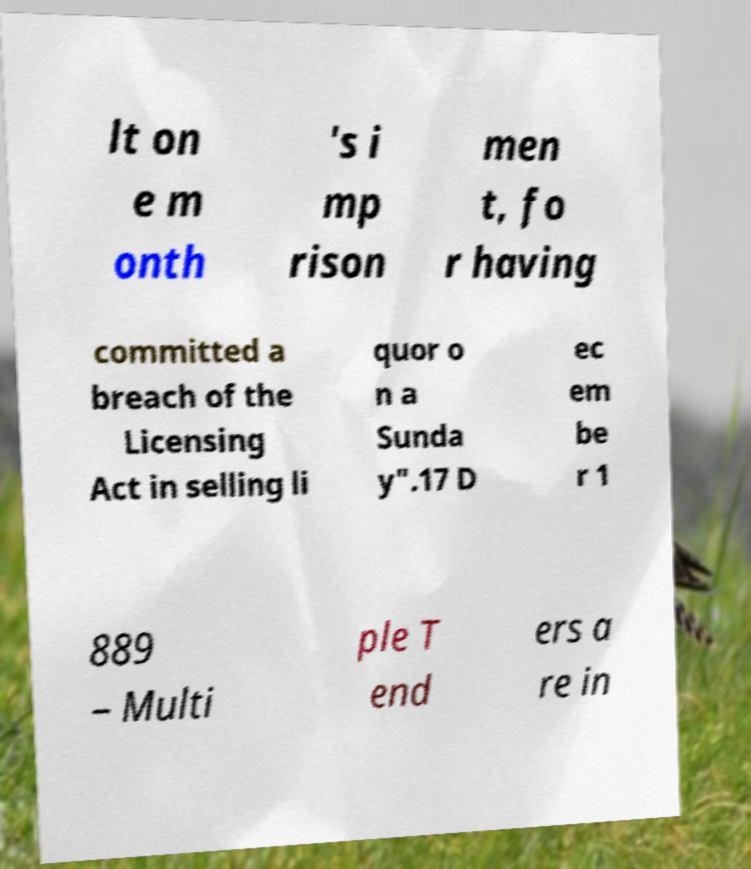Can you read and provide the text displayed in the image?This photo seems to have some interesting text. Can you extract and type it out for me? lt on e m onth 's i mp rison men t, fo r having committed a breach of the Licensing Act in selling li quor o n a Sunda y".17 D ec em be r 1 889 – Multi ple T end ers a re in 